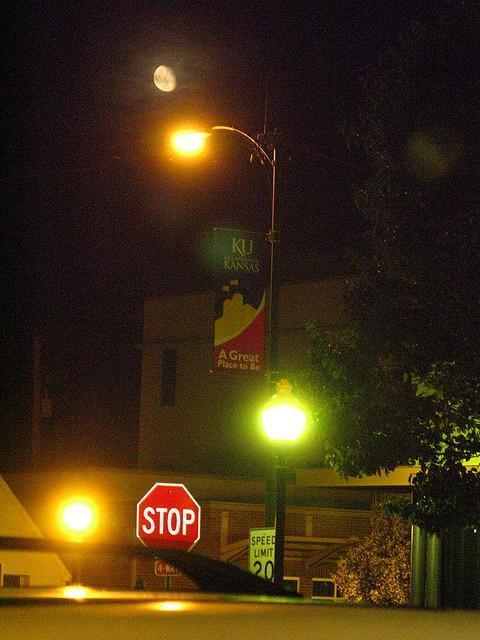How many cars are in the photo?
Give a very brief answer. 1. How many people are behind the train?
Give a very brief answer. 0. 